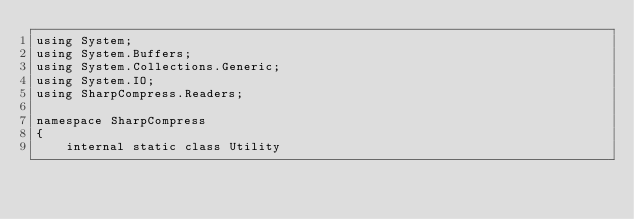<code> <loc_0><loc_0><loc_500><loc_500><_C#_>using System;
using System.Buffers;
using System.Collections.Generic;
using System.IO;
using SharpCompress.Readers;

namespace SharpCompress
{
    internal static class Utility</code> 